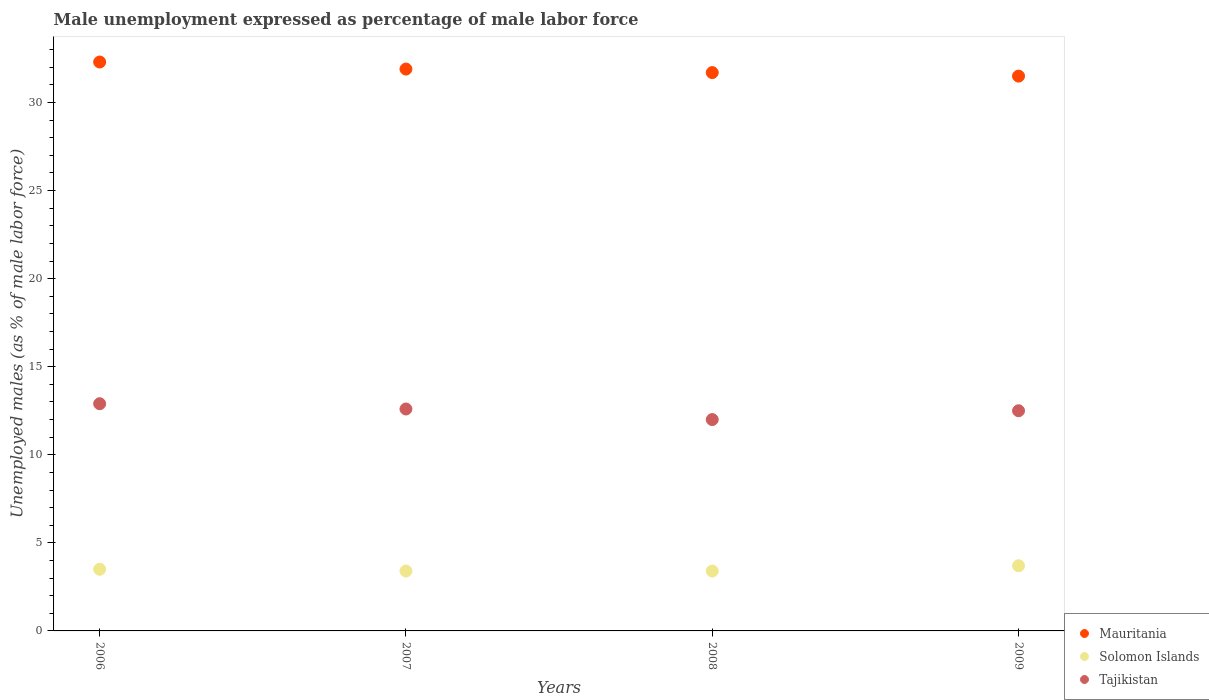How many different coloured dotlines are there?
Provide a succinct answer. 3. Is the number of dotlines equal to the number of legend labels?
Provide a short and direct response. Yes. What is the unemployment in males in in Mauritania in 2009?
Provide a succinct answer. 31.5. Across all years, what is the maximum unemployment in males in in Solomon Islands?
Your answer should be very brief. 3.7. Across all years, what is the minimum unemployment in males in in Solomon Islands?
Ensure brevity in your answer.  3.4. In which year was the unemployment in males in in Solomon Islands maximum?
Your response must be concise. 2009. In which year was the unemployment in males in in Tajikistan minimum?
Your answer should be compact. 2008. What is the total unemployment in males in in Mauritania in the graph?
Your answer should be compact. 127.4. What is the difference between the unemployment in males in in Mauritania in 2006 and that in 2007?
Offer a very short reply. 0.4. What is the difference between the unemployment in males in in Tajikistan in 2007 and the unemployment in males in in Mauritania in 2009?
Provide a succinct answer. -18.9. What is the average unemployment in males in in Mauritania per year?
Give a very brief answer. 31.85. In the year 2009, what is the difference between the unemployment in males in in Solomon Islands and unemployment in males in in Tajikistan?
Your answer should be compact. -8.8. What is the ratio of the unemployment in males in in Tajikistan in 2006 to that in 2007?
Ensure brevity in your answer.  1.02. Is the unemployment in males in in Tajikistan in 2007 less than that in 2009?
Offer a very short reply. No. Is the difference between the unemployment in males in in Solomon Islands in 2007 and 2008 greater than the difference between the unemployment in males in in Tajikistan in 2007 and 2008?
Ensure brevity in your answer.  No. What is the difference between the highest and the second highest unemployment in males in in Tajikistan?
Keep it short and to the point. 0.3. What is the difference between the highest and the lowest unemployment in males in in Solomon Islands?
Keep it short and to the point. 0.3. Is it the case that in every year, the sum of the unemployment in males in in Tajikistan and unemployment in males in in Solomon Islands  is greater than the unemployment in males in in Mauritania?
Provide a short and direct response. No. Is the unemployment in males in in Tajikistan strictly greater than the unemployment in males in in Solomon Islands over the years?
Keep it short and to the point. Yes. How many years are there in the graph?
Keep it short and to the point. 4. Are the values on the major ticks of Y-axis written in scientific E-notation?
Keep it short and to the point. No. How many legend labels are there?
Give a very brief answer. 3. What is the title of the graph?
Offer a terse response. Male unemployment expressed as percentage of male labor force. Does "Singapore" appear as one of the legend labels in the graph?
Keep it short and to the point. No. What is the label or title of the X-axis?
Your answer should be very brief. Years. What is the label or title of the Y-axis?
Your answer should be compact. Unemployed males (as % of male labor force). What is the Unemployed males (as % of male labor force) of Mauritania in 2006?
Your answer should be very brief. 32.3. What is the Unemployed males (as % of male labor force) in Solomon Islands in 2006?
Your answer should be compact. 3.5. What is the Unemployed males (as % of male labor force) of Tajikistan in 2006?
Offer a very short reply. 12.9. What is the Unemployed males (as % of male labor force) of Mauritania in 2007?
Offer a very short reply. 31.9. What is the Unemployed males (as % of male labor force) of Solomon Islands in 2007?
Your response must be concise. 3.4. What is the Unemployed males (as % of male labor force) in Tajikistan in 2007?
Give a very brief answer. 12.6. What is the Unemployed males (as % of male labor force) in Mauritania in 2008?
Offer a terse response. 31.7. What is the Unemployed males (as % of male labor force) of Solomon Islands in 2008?
Ensure brevity in your answer.  3.4. What is the Unemployed males (as % of male labor force) of Tajikistan in 2008?
Ensure brevity in your answer.  12. What is the Unemployed males (as % of male labor force) of Mauritania in 2009?
Give a very brief answer. 31.5. What is the Unemployed males (as % of male labor force) of Solomon Islands in 2009?
Your response must be concise. 3.7. What is the Unemployed males (as % of male labor force) of Tajikistan in 2009?
Ensure brevity in your answer.  12.5. Across all years, what is the maximum Unemployed males (as % of male labor force) of Mauritania?
Make the answer very short. 32.3. Across all years, what is the maximum Unemployed males (as % of male labor force) in Solomon Islands?
Keep it short and to the point. 3.7. Across all years, what is the maximum Unemployed males (as % of male labor force) of Tajikistan?
Offer a very short reply. 12.9. Across all years, what is the minimum Unemployed males (as % of male labor force) of Mauritania?
Provide a short and direct response. 31.5. Across all years, what is the minimum Unemployed males (as % of male labor force) in Solomon Islands?
Your answer should be very brief. 3.4. What is the total Unemployed males (as % of male labor force) of Mauritania in the graph?
Your response must be concise. 127.4. What is the difference between the Unemployed males (as % of male labor force) of Mauritania in 2006 and that in 2008?
Make the answer very short. 0.6. What is the difference between the Unemployed males (as % of male labor force) in Tajikistan in 2006 and that in 2008?
Give a very brief answer. 0.9. What is the difference between the Unemployed males (as % of male labor force) in Mauritania in 2006 and that in 2009?
Give a very brief answer. 0.8. What is the difference between the Unemployed males (as % of male labor force) in Solomon Islands in 2006 and that in 2009?
Offer a very short reply. -0.2. What is the difference between the Unemployed males (as % of male labor force) of Tajikistan in 2006 and that in 2009?
Your answer should be very brief. 0.4. What is the difference between the Unemployed males (as % of male labor force) in Solomon Islands in 2007 and that in 2009?
Your answer should be very brief. -0.3. What is the difference between the Unemployed males (as % of male labor force) of Tajikistan in 2007 and that in 2009?
Ensure brevity in your answer.  0.1. What is the difference between the Unemployed males (as % of male labor force) in Solomon Islands in 2008 and that in 2009?
Your answer should be compact. -0.3. What is the difference between the Unemployed males (as % of male labor force) of Tajikistan in 2008 and that in 2009?
Provide a succinct answer. -0.5. What is the difference between the Unemployed males (as % of male labor force) of Mauritania in 2006 and the Unemployed males (as % of male labor force) of Solomon Islands in 2007?
Make the answer very short. 28.9. What is the difference between the Unemployed males (as % of male labor force) of Mauritania in 2006 and the Unemployed males (as % of male labor force) of Tajikistan in 2007?
Offer a terse response. 19.7. What is the difference between the Unemployed males (as % of male labor force) in Mauritania in 2006 and the Unemployed males (as % of male labor force) in Solomon Islands in 2008?
Provide a succinct answer. 28.9. What is the difference between the Unemployed males (as % of male labor force) in Mauritania in 2006 and the Unemployed males (as % of male labor force) in Tajikistan in 2008?
Keep it short and to the point. 20.3. What is the difference between the Unemployed males (as % of male labor force) of Solomon Islands in 2006 and the Unemployed males (as % of male labor force) of Tajikistan in 2008?
Give a very brief answer. -8.5. What is the difference between the Unemployed males (as % of male labor force) of Mauritania in 2006 and the Unemployed males (as % of male labor force) of Solomon Islands in 2009?
Provide a succinct answer. 28.6. What is the difference between the Unemployed males (as % of male labor force) of Mauritania in 2006 and the Unemployed males (as % of male labor force) of Tajikistan in 2009?
Make the answer very short. 19.8. What is the difference between the Unemployed males (as % of male labor force) in Solomon Islands in 2006 and the Unemployed males (as % of male labor force) in Tajikistan in 2009?
Your answer should be compact. -9. What is the difference between the Unemployed males (as % of male labor force) in Mauritania in 2007 and the Unemployed males (as % of male labor force) in Solomon Islands in 2008?
Offer a terse response. 28.5. What is the difference between the Unemployed males (as % of male labor force) in Mauritania in 2007 and the Unemployed males (as % of male labor force) in Solomon Islands in 2009?
Ensure brevity in your answer.  28.2. What is the difference between the Unemployed males (as % of male labor force) of Solomon Islands in 2008 and the Unemployed males (as % of male labor force) of Tajikistan in 2009?
Ensure brevity in your answer.  -9.1. What is the average Unemployed males (as % of male labor force) in Mauritania per year?
Provide a succinct answer. 31.85. What is the average Unemployed males (as % of male labor force) in Solomon Islands per year?
Keep it short and to the point. 3.5. What is the average Unemployed males (as % of male labor force) of Tajikistan per year?
Offer a very short reply. 12.5. In the year 2006, what is the difference between the Unemployed males (as % of male labor force) of Mauritania and Unemployed males (as % of male labor force) of Solomon Islands?
Provide a short and direct response. 28.8. In the year 2007, what is the difference between the Unemployed males (as % of male labor force) of Mauritania and Unemployed males (as % of male labor force) of Tajikistan?
Give a very brief answer. 19.3. In the year 2007, what is the difference between the Unemployed males (as % of male labor force) in Solomon Islands and Unemployed males (as % of male labor force) in Tajikistan?
Give a very brief answer. -9.2. In the year 2008, what is the difference between the Unemployed males (as % of male labor force) of Mauritania and Unemployed males (as % of male labor force) of Solomon Islands?
Provide a short and direct response. 28.3. In the year 2008, what is the difference between the Unemployed males (as % of male labor force) in Solomon Islands and Unemployed males (as % of male labor force) in Tajikistan?
Offer a terse response. -8.6. In the year 2009, what is the difference between the Unemployed males (as % of male labor force) in Mauritania and Unemployed males (as % of male labor force) in Solomon Islands?
Make the answer very short. 27.8. In the year 2009, what is the difference between the Unemployed males (as % of male labor force) of Solomon Islands and Unemployed males (as % of male labor force) of Tajikistan?
Your response must be concise. -8.8. What is the ratio of the Unemployed males (as % of male labor force) in Mauritania in 2006 to that in 2007?
Keep it short and to the point. 1.01. What is the ratio of the Unemployed males (as % of male labor force) of Solomon Islands in 2006 to that in 2007?
Your answer should be very brief. 1.03. What is the ratio of the Unemployed males (as % of male labor force) of Tajikistan in 2006 to that in 2007?
Your answer should be compact. 1.02. What is the ratio of the Unemployed males (as % of male labor force) in Mauritania in 2006 to that in 2008?
Ensure brevity in your answer.  1.02. What is the ratio of the Unemployed males (as % of male labor force) in Solomon Islands in 2006 to that in 2008?
Ensure brevity in your answer.  1.03. What is the ratio of the Unemployed males (as % of male labor force) of Tajikistan in 2006 to that in 2008?
Provide a succinct answer. 1.07. What is the ratio of the Unemployed males (as % of male labor force) in Mauritania in 2006 to that in 2009?
Your answer should be compact. 1.03. What is the ratio of the Unemployed males (as % of male labor force) in Solomon Islands in 2006 to that in 2009?
Make the answer very short. 0.95. What is the ratio of the Unemployed males (as % of male labor force) in Tajikistan in 2006 to that in 2009?
Give a very brief answer. 1.03. What is the ratio of the Unemployed males (as % of male labor force) in Tajikistan in 2007 to that in 2008?
Ensure brevity in your answer.  1.05. What is the ratio of the Unemployed males (as % of male labor force) of Mauritania in 2007 to that in 2009?
Your response must be concise. 1.01. What is the ratio of the Unemployed males (as % of male labor force) of Solomon Islands in 2007 to that in 2009?
Your response must be concise. 0.92. What is the ratio of the Unemployed males (as % of male labor force) in Solomon Islands in 2008 to that in 2009?
Provide a short and direct response. 0.92. What is the ratio of the Unemployed males (as % of male labor force) of Tajikistan in 2008 to that in 2009?
Your answer should be compact. 0.96. What is the difference between the highest and the second highest Unemployed males (as % of male labor force) in Mauritania?
Provide a succinct answer. 0.4. What is the difference between the highest and the second highest Unemployed males (as % of male labor force) of Solomon Islands?
Offer a very short reply. 0.2. What is the difference between the highest and the second highest Unemployed males (as % of male labor force) of Tajikistan?
Your answer should be compact. 0.3. What is the difference between the highest and the lowest Unemployed males (as % of male labor force) of Tajikistan?
Give a very brief answer. 0.9. 